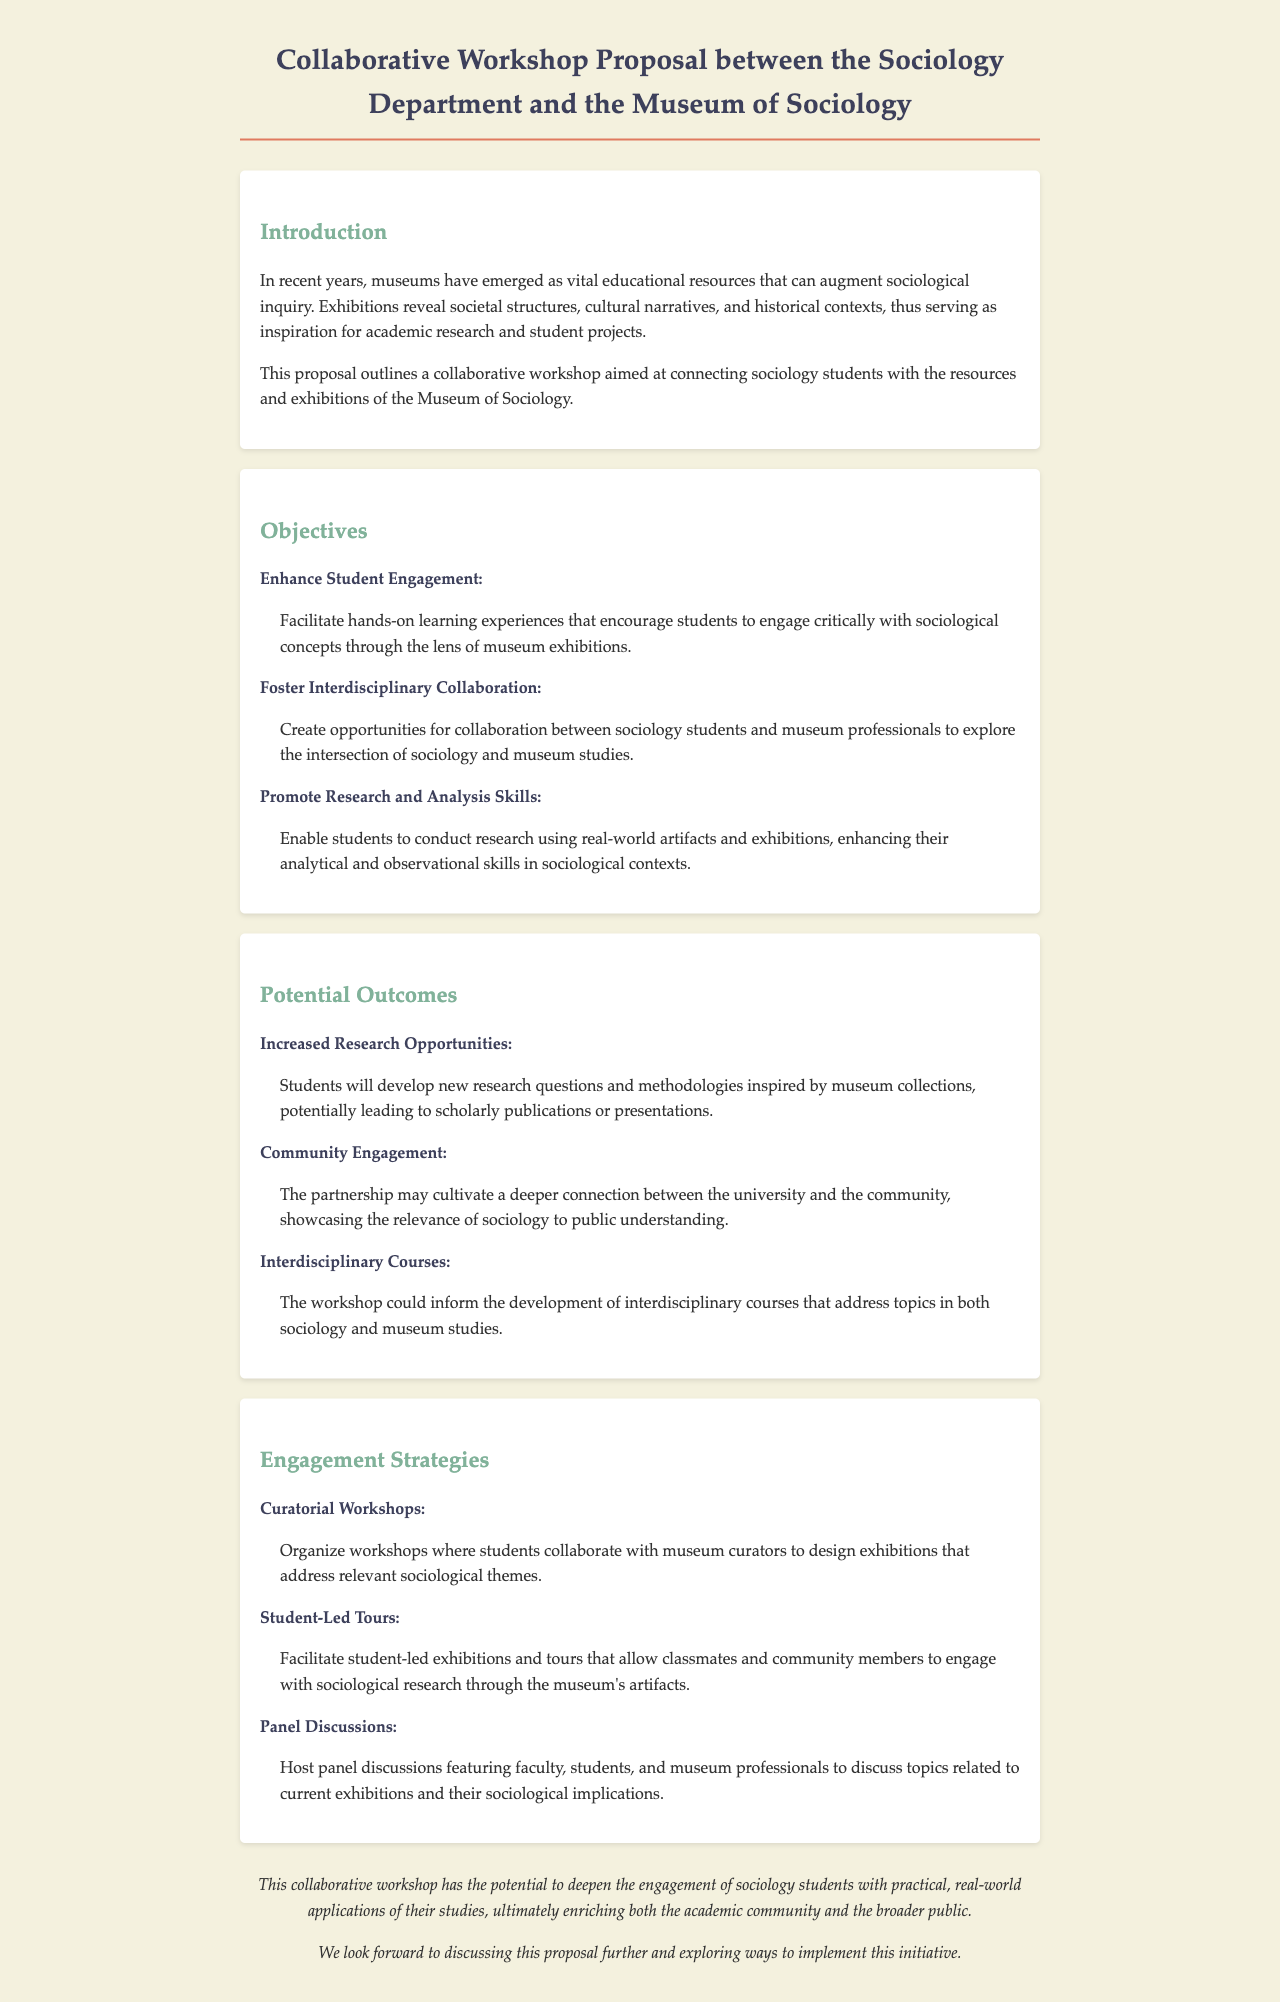What is the title of the document? The title is located at the top of the document, indicating the subject of the proposal.
Answer: Collaborative Workshop Proposal between the Sociology Department and the Museum of Sociology How many objectives are listed in the proposal? The number of objectives can be counted in the section detailing the objectives, which contains a list.
Answer: Three What is the first potential outcome mentioned? The potential outcomes are enumerated; the first one is explicitly stated.
Answer: Increased Research Opportunities What engagement strategy involves curators? The strategies listed include several forms of engagement, one of which involves collaboration with curators.
Answer: Curatorial Workshops What is the key focus of the workshop proposal? The proposal highlights its main goal in the introduction, which summarizes the overall aim.
Answer: Connecting sociology students with the resources and exhibitions of the Museum of Sociology What role do panel discussions play in the engagement strategies? The details about panel discussions are found in the section explaining engagement strategies, outlining their purpose.
Answer: Discuss sociological implications What is one of the objectives related to research skills? The objectives specify enhancing certain skills, and one objective directly addresses research skills.
Answer: Promote Research and Analysis Skills What type of community connection is expected from the workshop? The expected community outcome related to engagement is clearly stated in the potential outcomes section.
Answer: Community Engagement 